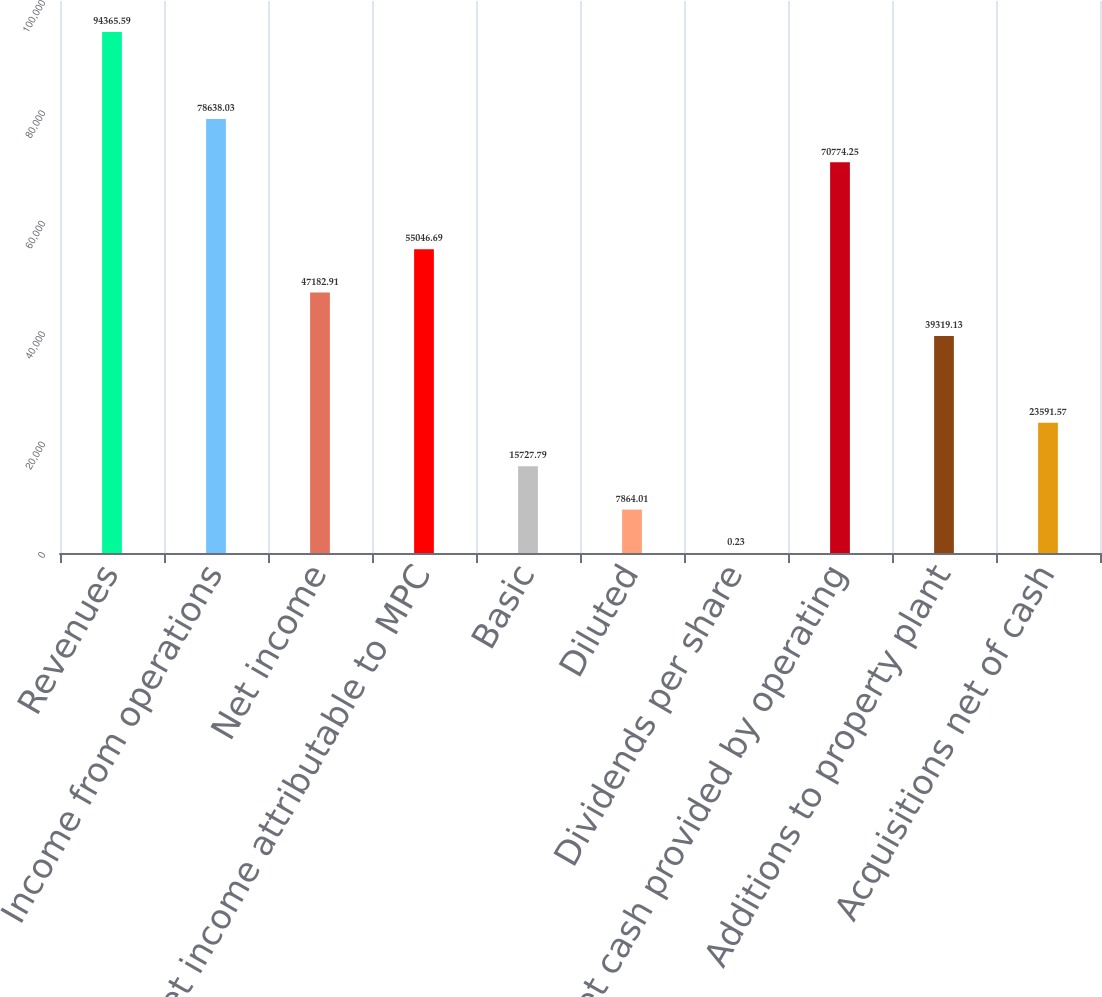Convert chart. <chart><loc_0><loc_0><loc_500><loc_500><bar_chart><fcel>Revenues<fcel>Income from operations<fcel>Net income<fcel>Net income attributable to MPC<fcel>Basic<fcel>Diluted<fcel>Dividends per share<fcel>Net cash provided by operating<fcel>Additions to property plant<fcel>Acquisitions net of cash<nl><fcel>94365.6<fcel>78638<fcel>47182.9<fcel>55046.7<fcel>15727.8<fcel>7864.01<fcel>0.23<fcel>70774.2<fcel>39319.1<fcel>23591.6<nl></chart> 